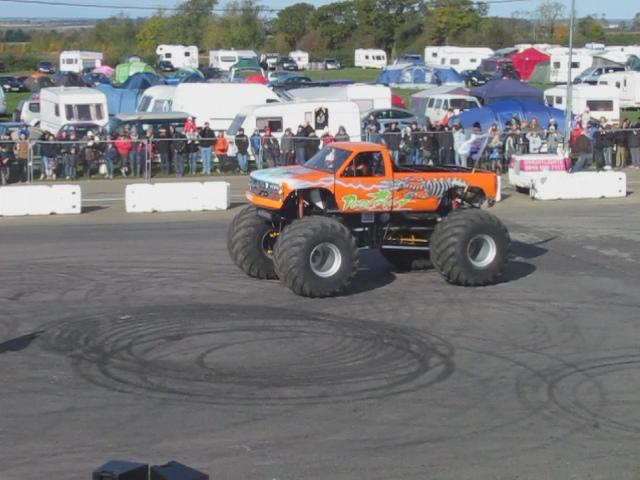What are the circular patterns on the ground? Please explain your reasoning. tire tracks. The circular patterns on the ground are left from tires when the car spun very fast. 